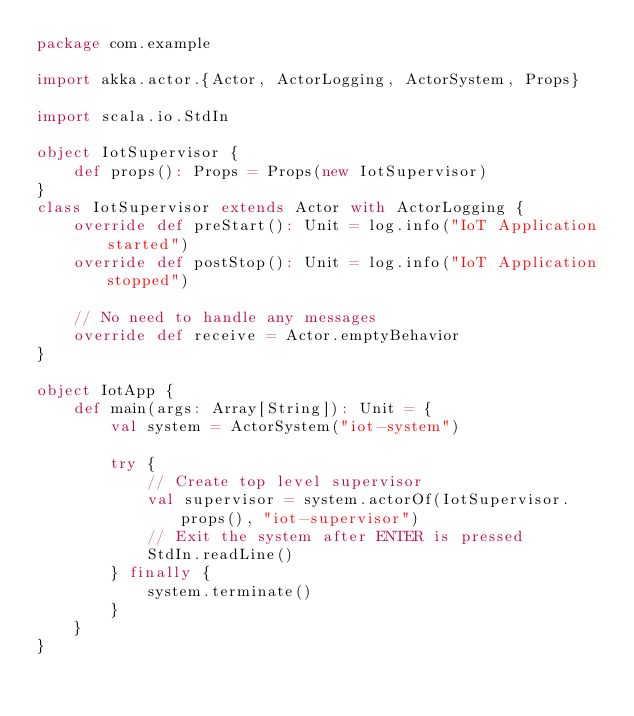<code> <loc_0><loc_0><loc_500><loc_500><_Scala_>package com.example

import akka.actor.{Actor, ActorLogging, ActorSystem, Props}

import scala.io.StdIn

object IotSupervisor {
    def props(): Props = Props(new IotSupervisor)
}
class IotSupervisor extends Actor with ActorLogging {
    override def preStart(): Unit = log.info("IoT Application started")
    override def postStop(): Unit = log.info("IoT Application stopped")

    // No need to handle any messages
    override def receive = Actor.emptyBehavior
}

object IotApp {
    def main(args: Array[String]): Unit = {
        val system = ActorSystem("iot-system")

        try {
            // Create top level supervisor
            val supervisor = system.actorOf(IotSupervisor.props(), "iot-supervisor")
            // Exit the system after ENTER is pressed
            StdIn.readLine()
        } finally {
            system.terminate()
        }
    }
}</code> 